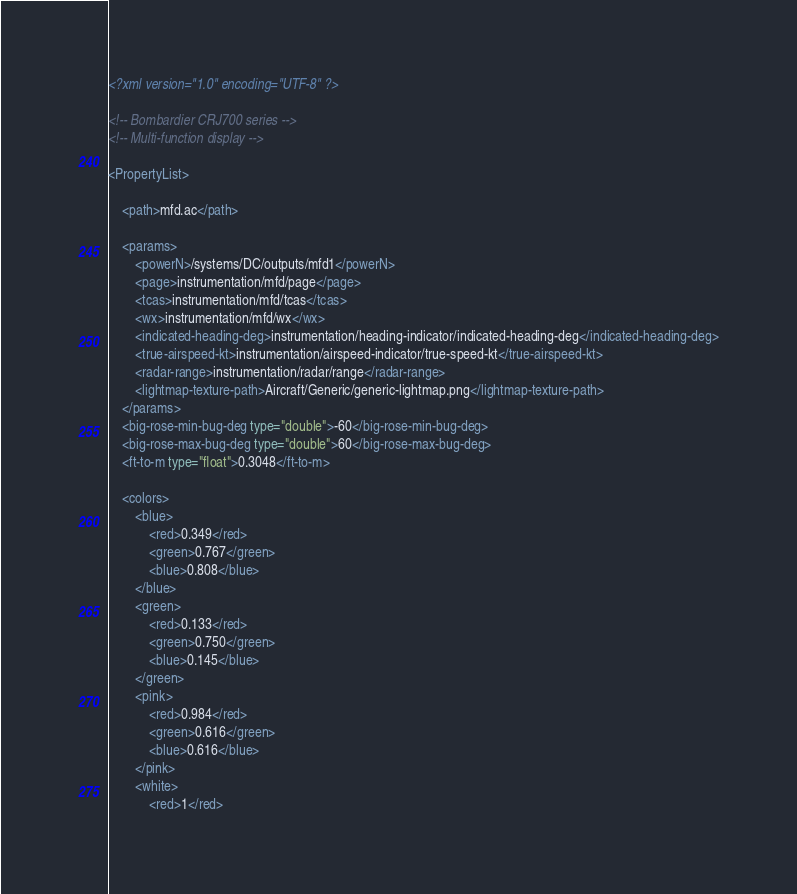<code> <loc_0><loc_0><loc_500><loc_500><_XML_><?xml version="1.0" encoding="UTF-8" ?>

<!-- Bombardier CRJ700 series -->
<!-- Multi-function display -->

<PropertyList>
	
    <path>mfd.ac</path>
	
    <params>
		<powerN>/systems/DC/outputs/mfd1</powerN>	
		<page>instrumentation/mfd/page</page>
		<tcas>instrumentation/mfd/tcas</tcas>
		<wx>instrumentation/mfd/wx</wx>
		<indicated-heading-deg>instrumentation/heading-indicator/indicated-heading-deg</indicated-heading-deg>
		<true-airspeed-kt>instrumentation/airspeed-indicator/true-speed-kt</true-airspeed-kt>
		<radar-range>instrumentation/radar/range</radar-range>
		<lightmap-texture-path>Aircraft/Generic/generic-lightmap.png</lightmap-texture-path>
	</params>
    <big-rose-min-bug-deg type="double">-60</big-rose-min-bug-deg>
    <big-rose-max-bug-deg type="double">60</big-rose-max-bug-deg>
    <ft-to-m type="float">0.3048</ft-to-m>
	
    <colors>
		<blue>
			<red>0.349</red>
			<green>0.767</green>
			<blue>0.808</blue>
		</blue>
		<green>
			<red>0.133</red>
			<green>0.750</green>
			<blue>0.145</blue>
		</green>
		<pink>
			<red>0.984</red>
			<green>0.616</green>
			<blue>0.616</blue>
		</pink>
		<white>
			<red>1</red></code> 